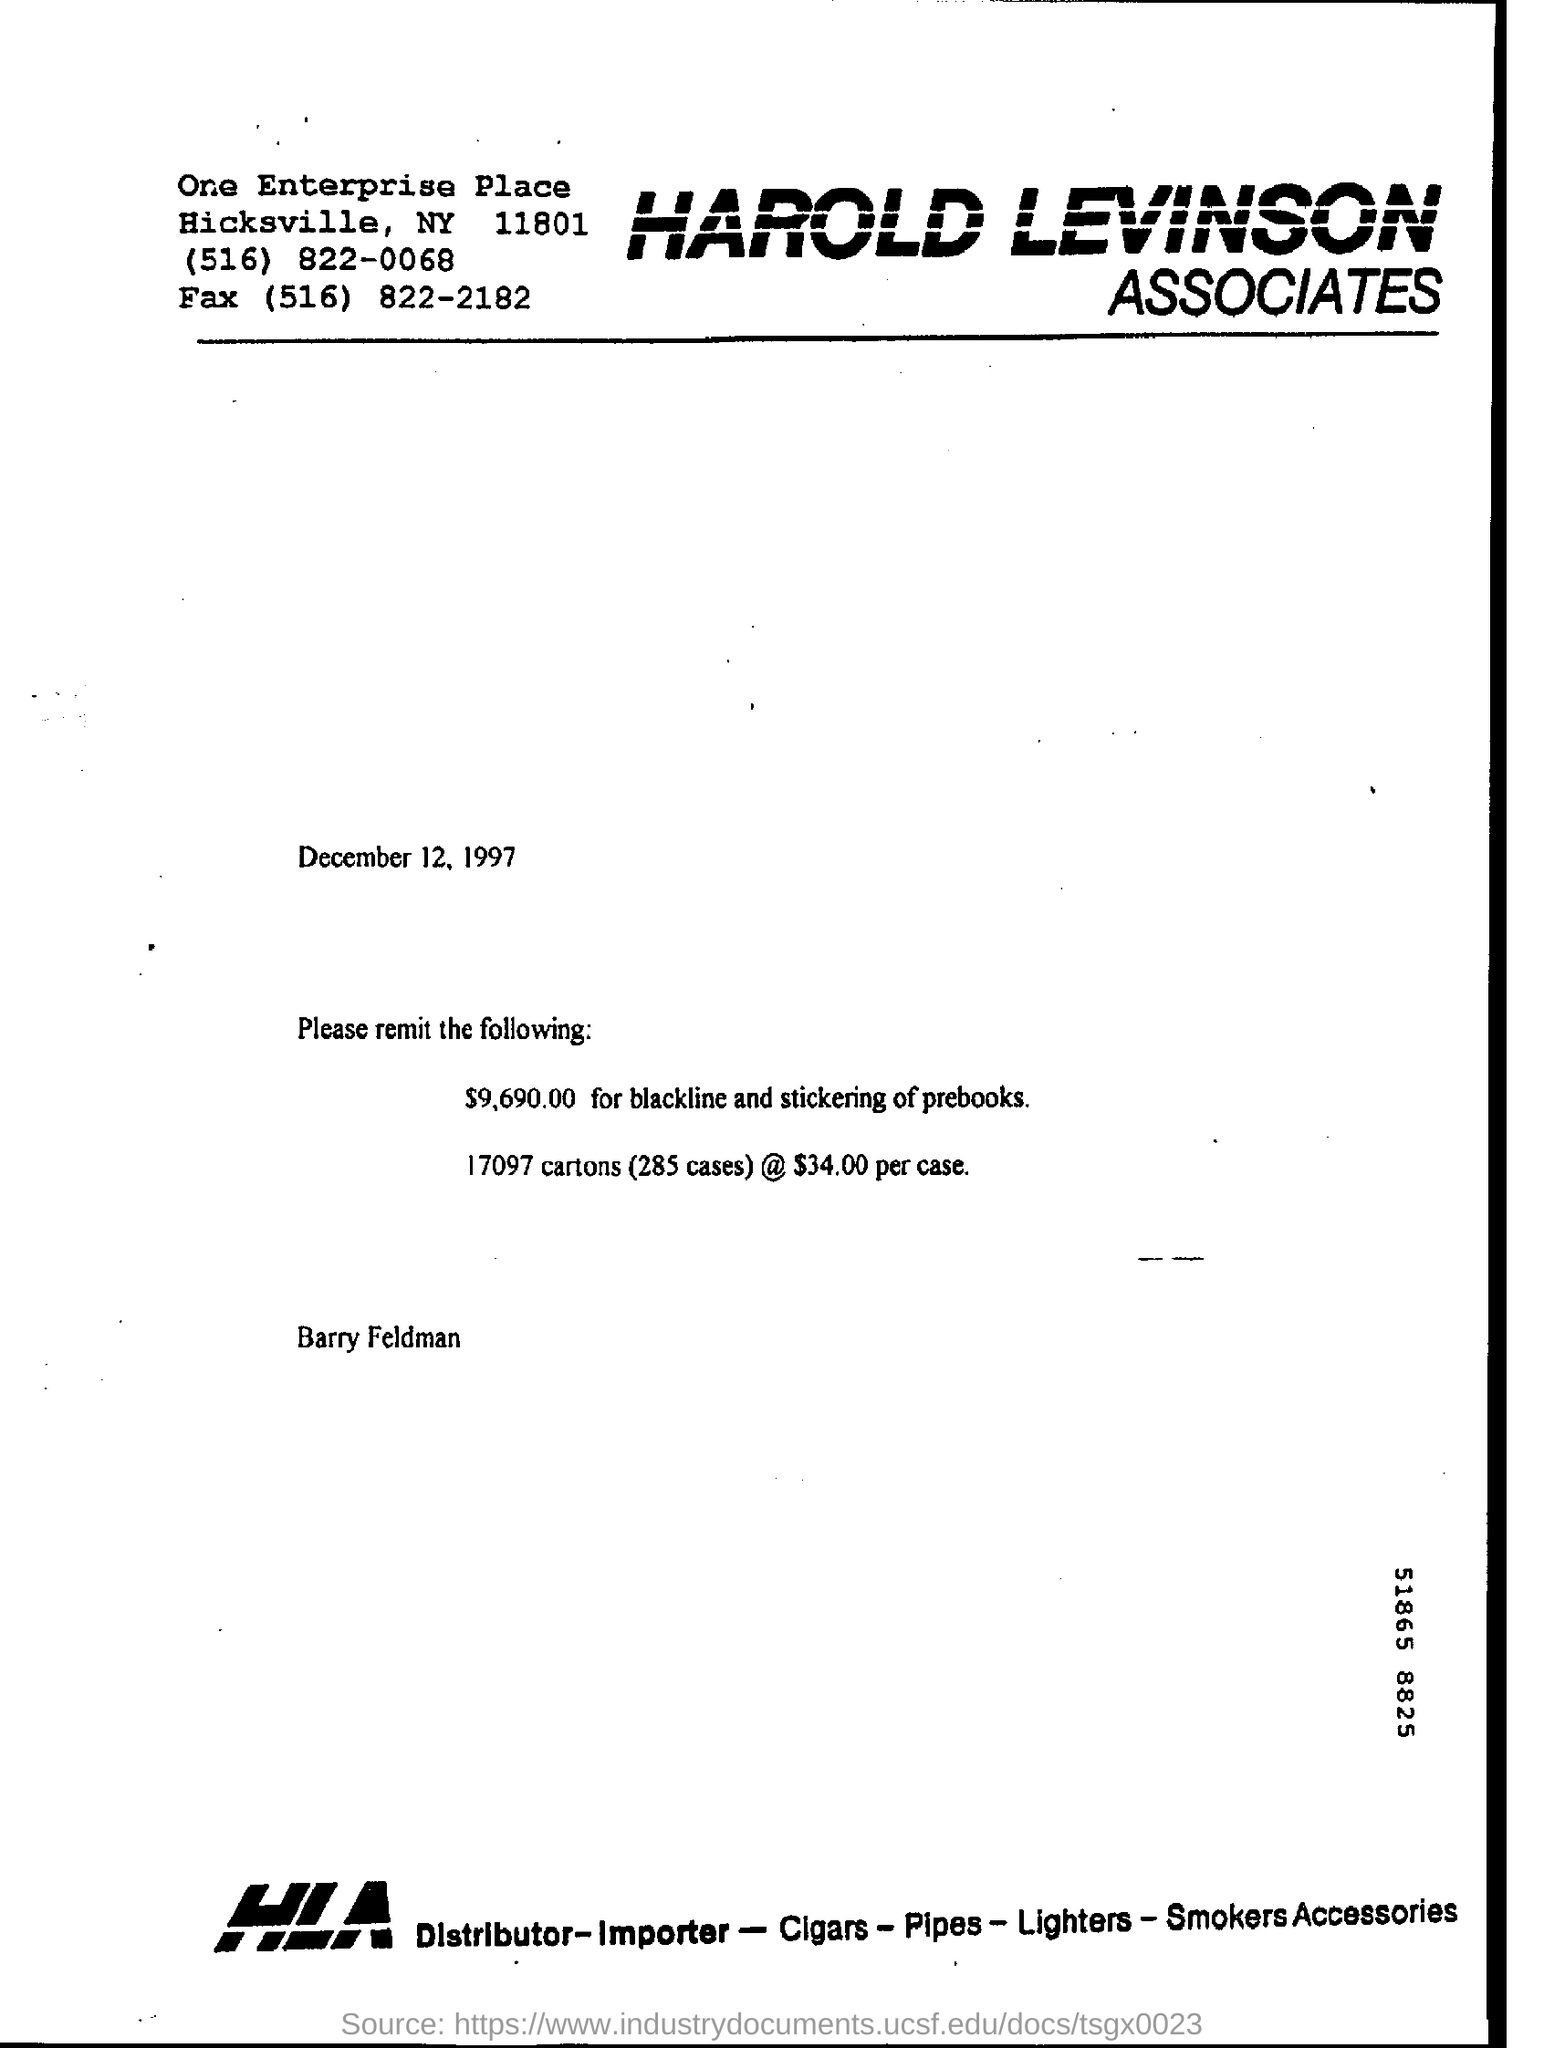What does HLA stands for?
Your answer should be very brief. Harold Levinson Associates. How much money has been spent for black line and stickering of prebooks?
Give a very brief answer. $9,690.00. 